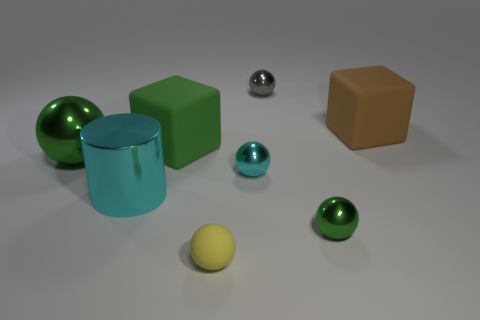Subtract all spheres. How many objects are left? 3 Subtract 2 spheres. How many spheres are left? 3 Subtract all yellow cylinders. Subtract all gray spheres. How many cylinders are left? 1 Subtract all cyan cylinders. How many yellow balls are left? 1 Subtract all gray objects. Subtract all big things. How many objects are left? 3 Add 5 yellow spheres. How many yellow spheres are left? 6 Add 1 spheres. How many spheres exist? 6 Add 2 small purple objects. How many objects exist? 10 Subtract all yellow balls. How many balls are left? 4 Subtract all large metal balls. How many balls are left? 4 